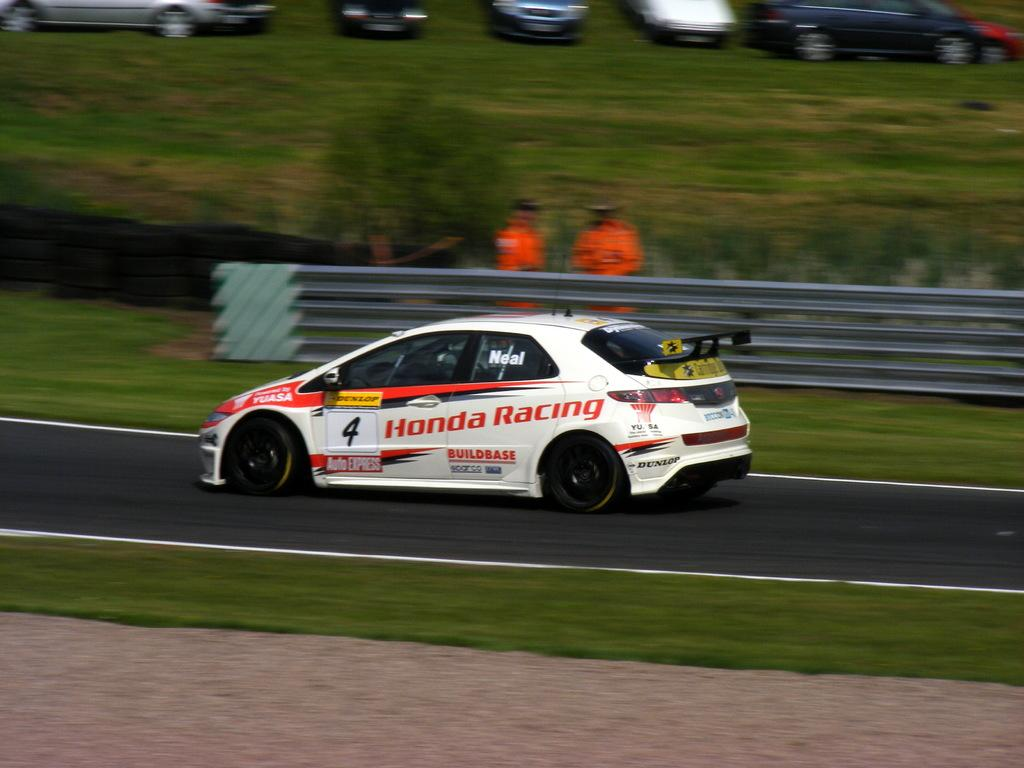<image>
Share a concise interpretation of the image provided. A white care with a number 4 of the side with "Honda Racing" in orange letters behind it. 